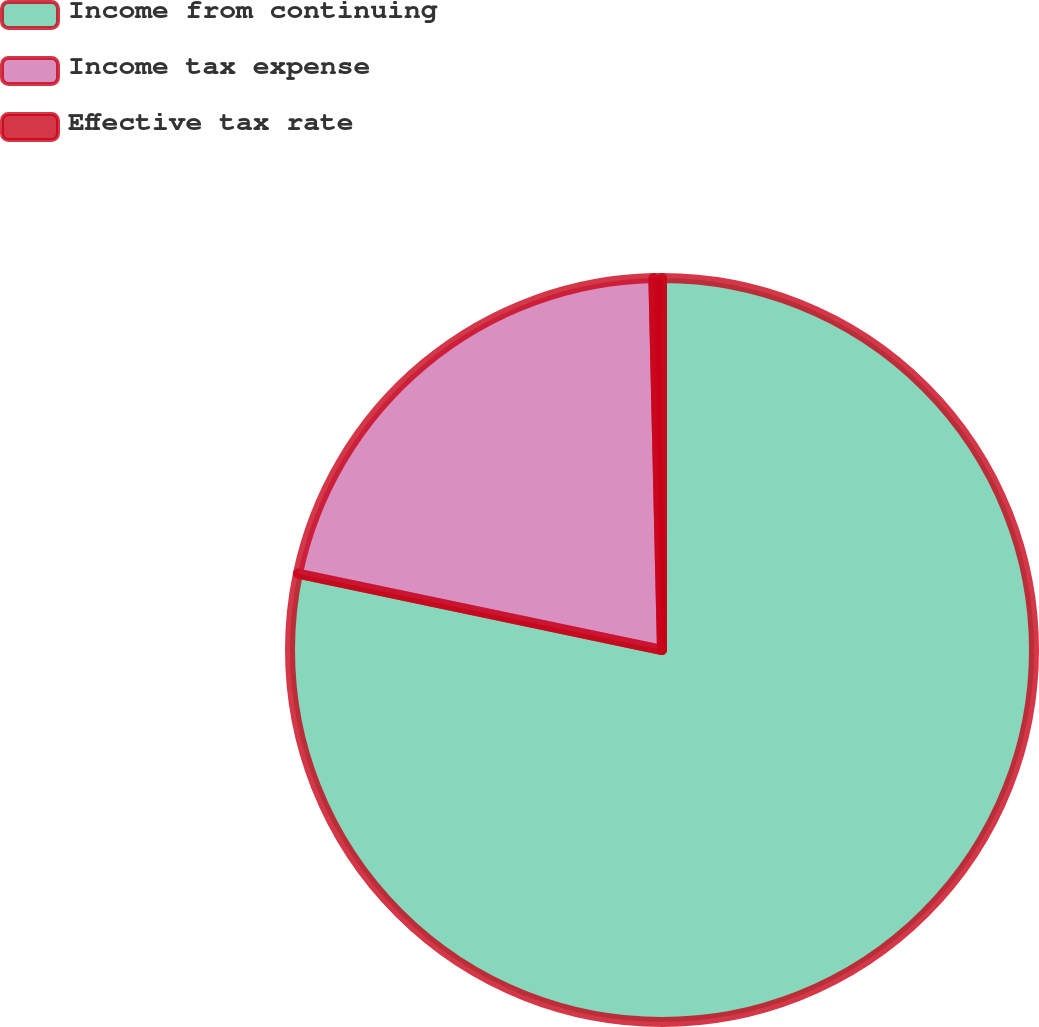Convert chart. <chart><loc_0><loc_0><loc_500><loc_500><pie_chart><fcel>Income from continuing<fcel>Income tax expense<fcel>Effective tax rate<nl><fcel>78.3%<fcel>21.34%<fcel>0.37%<nl></chart> 